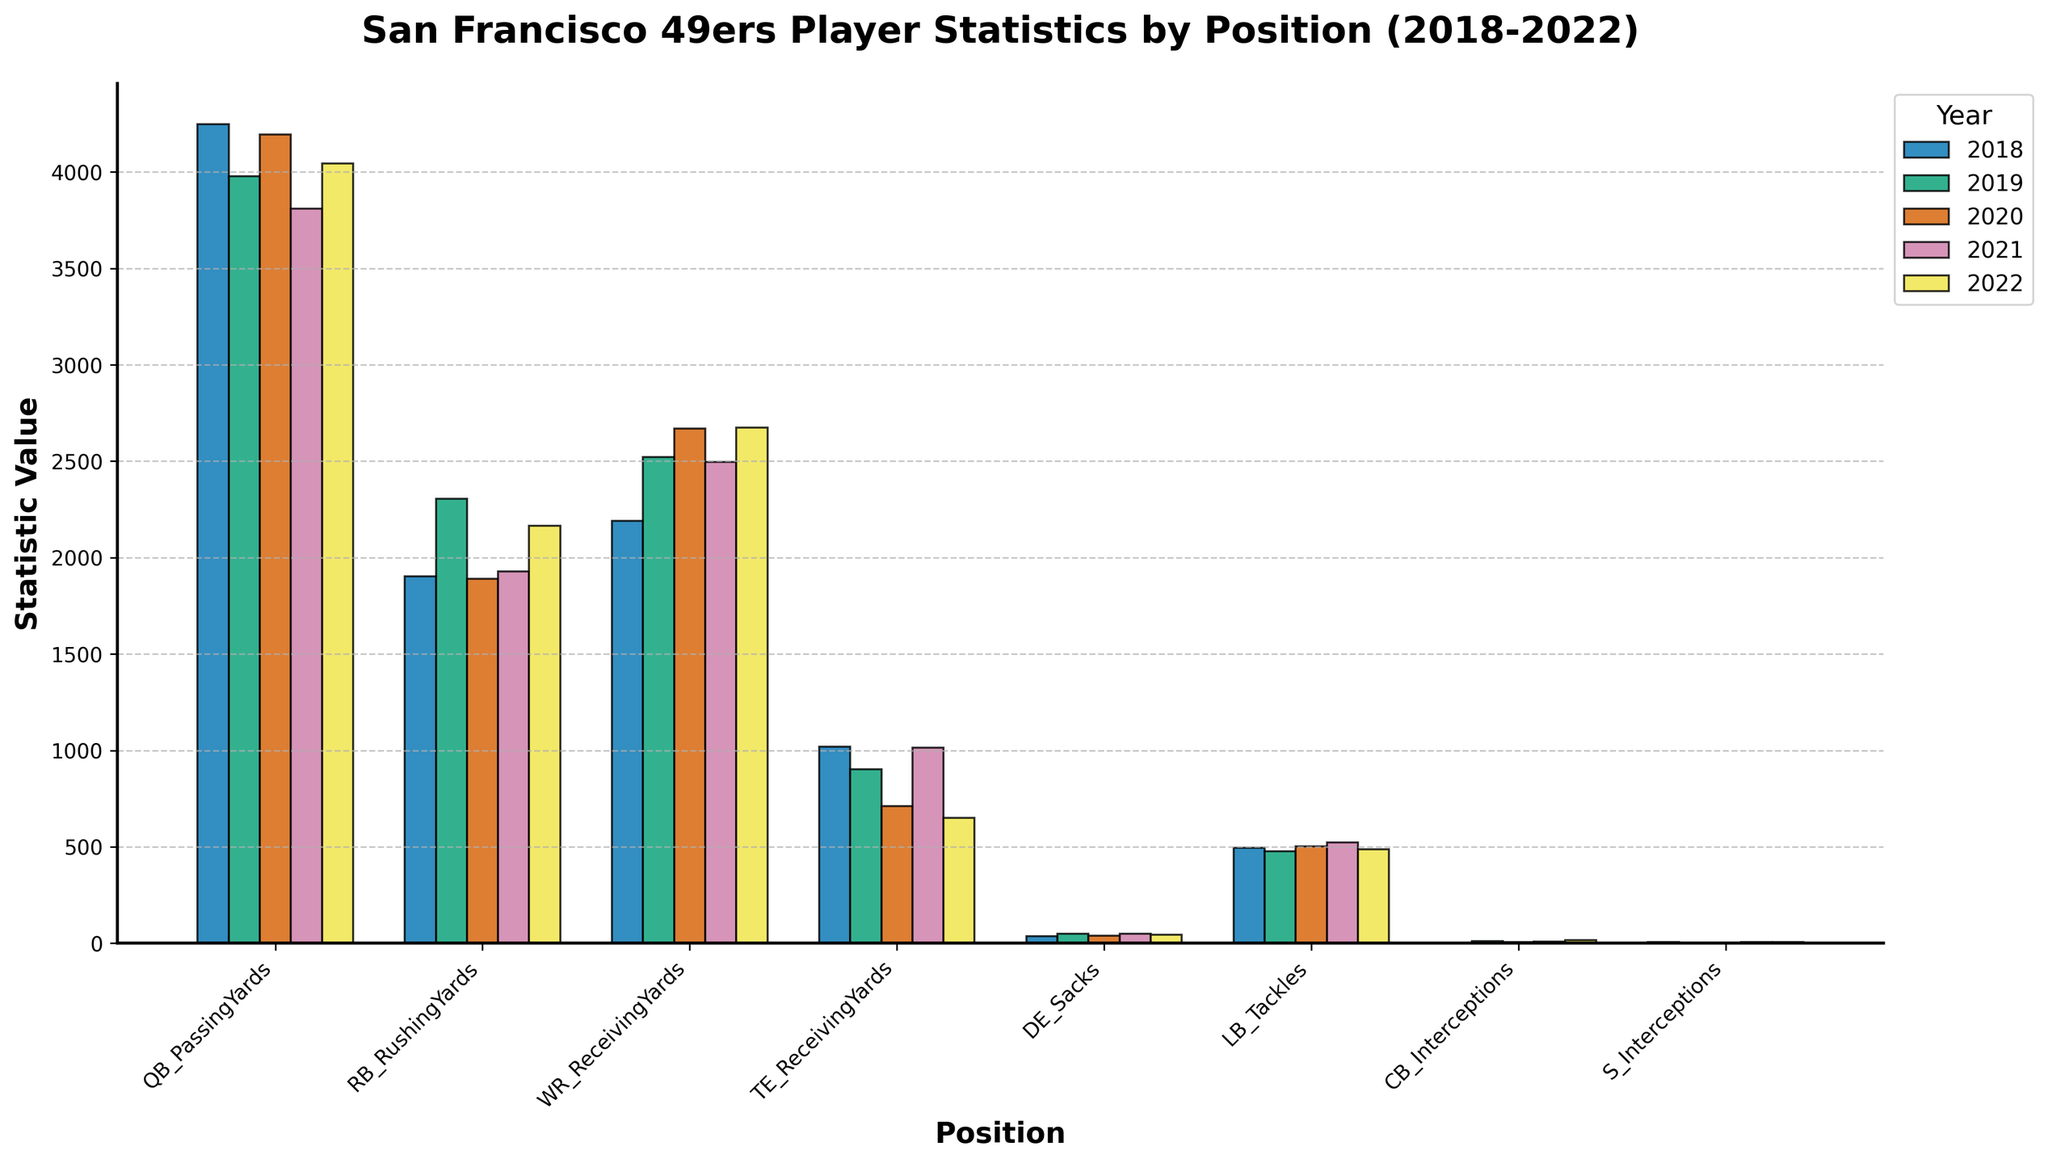Which position had the highest passing yards in 2018? Refer to the bar heights for passing yards in 2018, the highest bar is for the QB position.
Answer: QB How many more receiving yards did the WR position have in 2022 compared to the TE position? Find the bar heights of WR and TE for 2022. WR has 2673 receiving yards and TE has 649 receiving yards. Subtract TE from WR: 2673 - 649 = 2024.
Answer: 2024 What was the average number of sacks for the DE position over the 5 seasons? Add the sack numbers for DE over the 5 seasons and divide by 5: (37 + 48 + 39 + 48 + 44) / 5 = 216 / 5 = 43.2.
Answer: 43.2 Which year saw the highest number of interceptions by the CB position? Look at the bars for CB interceptions over the years. The highest bar is in 2022 with 15 interceptions.
Answer: 2022 Compare the total rushing yards by the RB position in 2019 and 2021, and indicate which year had more rushing yards and by how much. RB rushing yards in 2019 is 2305 and in 2021 is 1928. Subtract the two: 2305 - 1928 = 377. 2019 had more rushing yards by 377.
Answer: 2019, 377 Determine the difference in total receiving yards between the WR and TE positions in 2020. WR receiving yards in 2020 is 2670 and TE receiving yards in 2020 is 712. Subtract TE from WR: 2670 - 712 = 1958.
Answer: 1958 Which position showed the most consistent performance in terms of interceptions over the 5 seasons? Look at the bars for interceptions for CB and S over the years. S interceptions remain closest with values 5, 4, 4, 6, 5.
Answer: S What were the total number of tackles by the LB position in 2020 and 2021 combined? Add the tackle numbers for LB in 2020 and 2021: 503 + 522 = 1025.
Answer: 1025 How did the receiving yards for WR position in 2021 compare to 2020? Look at the bar heights for WR receiving yards in 2021 (2495) and 2020 (2670). Subtract 2021 from 2020: 2670 - 2495 = 175. WR had 175 fewer receiving yards in 2021.
Answer: 175 fewer 